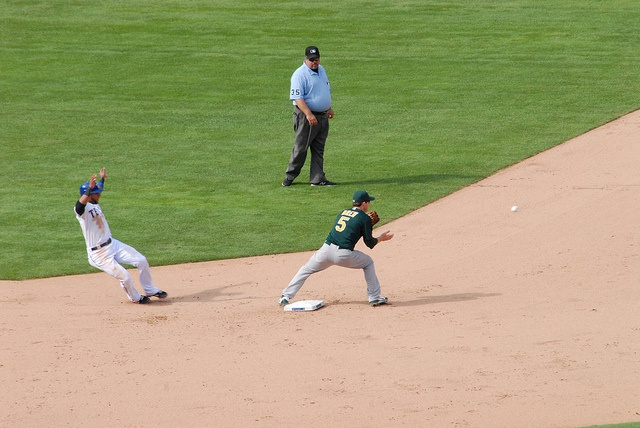Describe the objects in this image and their specific colors. I can see people in olive, black, gray, and darkgray tones, people in olive, black, darkgray, lightgray, and teal tones, people in olive, lavender, darkgray, and black tones, baseball glove in olive, maroon, black, and brown tones, and sports ball in lightgray, darkgray, olive, and white tones in this image. 